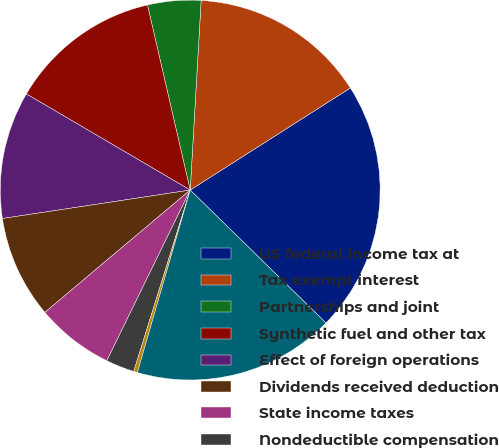Convert chart. <chart><loc_0><loc_0><loc_500><loc_500><pie_chart><fcel>US federal income tax at<fcel>Tax exempt interest<fcel>Partnerships and joint<fcel>Synthetic fuel and other tax<fcel>Effect of foreign operations<fcel>Dividends received deduction<fcel>State income taxes<fcel>Nondeductible compensation<fcel>Other<fcel>Actual income tax expense<nl><fcel>21.36%<fcel>15.05%<fcel>4.53%<fcel>12.94%<fcel>10.84%<fcel>8.74%<fcel>6.63%<fcel>2.43%<fcel>0.32%<fcel>17.15%<nl></chart> 